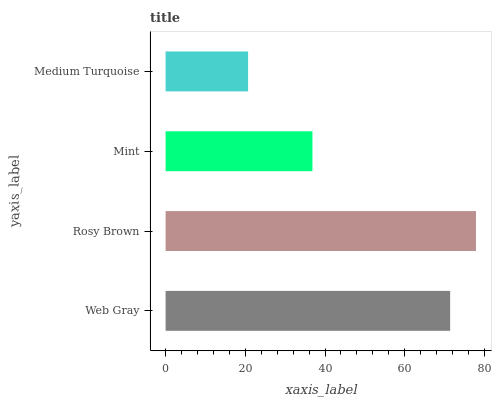Is Medium Turquoise the minimum?
Answer yes or no. Yes. Is Rosy Brown the maximum?
Answer yes or no. Yes. Is Mint the minimum?
Answer yes or no. No. Is Mint the maximum?
Answer yes or no. No. Is Rosy Brown greater than Mint?
Answer yes or no. Yes. Is Mint less than Rosy Brown?
Answer yes or no. Yes. Is Mint greater than Rosy Brown?
Answer yes or no. No. Is Rosy Brown less than Mint?
Answer yes or no. No. Is Web Gray the high median?
Answer yes or no. Yes. Is Mint the low median?
Answer yes or no. Yes. Is Mint the high median?
Answer yes or no. No. Is Web Gray the low median?
Answer yes or no. No. 